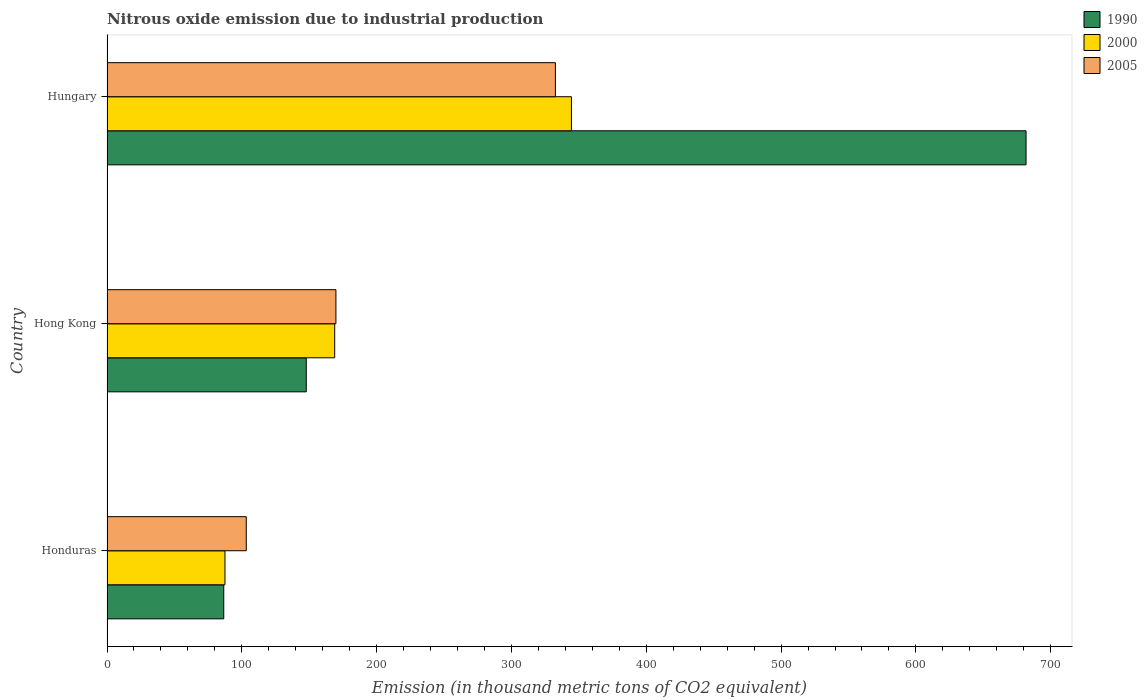How many different coloured bars are there?
Offer a very short reply. 3. How many groups of bars are there?
Provide a short and direct response. 3. Are the number of bars per tick equal to the number of legend labels?
Offer a terse response. Yes. Are the number of bars on each tick of the Y-axis equal?
Ensure brevity in your answer.  Yes. How many bars are there on the 2nd tick from the top?
Your answer should be very brief. 3. What is the label of the 2nd group of bars from the top?
Your response must be concise. Hong Kong. What is the amount of nitrous oxide emitted in 2000 in Hungary?
Provide a short and direct response. 344.5. Across all countries, what is the maximum amount of nitrous oxide emitted in 2000?
Provide a short and direct response. 344.5. Across all countries, what is the minimum amount of nitrous oxide emitted in 1990?
Your response must be concise. 86.6. In which country was the amount of nitrous oxide emitted in 1990 maximum?
Offer a very short reply. Hungary. In which country was the amount of nitrous oxide emitted in 2005 minimum?
Provide a short and direct response. Honduras. What is the total amount of nitrous oxide emitted in 1990 in the graph?
Your answer should be very brief. 916.1. What is the difference between the amount of nitrous oxide emitted in 2005 in Hong Kong and that in Hungary?
Your answer should be compact. -162.8. What is the difference between the amount of nitrous oxide emitted in 1990 in Hong Kong and the amount of nitrous oxide emitted in 2000 in Hungary?
Ensure brevity in your answer.  -196.7. What is the average amount of nitrous oxide emitted in 1990 per country?
Your answer should be compact. 305.37. What is the difference between the amount of nitrous oxide emitted in 2005 and amount of nitrous oxide emitted in 2000 in Hungary?
Your answer should be compact. -11.9. What is the ratio of the amount of nitrous oxide emitted in 2000 in Honduras to that in Hungary?
Provide a succinct answer. 0.25. Is the amount of nitrous oxide emitted in 1990 in Honduras less than that in Hong Kong?
Your response must be concise. Yes. Is the difference between the amount of nitrous oxide emitted in 2005 in Hong Kong and Hungary greater than the difference between the amount of nitrous oxide emitted in 2000 in Hong Kong and Hungary?
Your response must be concise. Yes. What is the difference between the highest and the second highest amount of nitrous oxide emitted in 2000?
Your answer should be very brief. 175.6. What is the difference between the highest and the lowest amount of nitrous oxide emitted in 1990?
Ensure brevity in your answer.  595.1. Is the sum of the amount of nitrous oxide emitted in 1990 in Honduras and Hong Kong greater than the maximum amount of nitrous oxide emitted in 2005 across all countries?
Offer a terse response. No. How many bars are there?
Offer a terse response. 9. Are all the bars in the graph horizontal?
Ensure brevity in your answer.  Yes. What is the difference between two consecutive major ticks on the X-axis?
Your answer should be very brief. 100. Are the values on the major ticks of X-axis written in scientific E-notation?
Make the answer very short. No. Does the graph contain any zero values?
Your answer should be compact. No. Where does the legend appear in the graph?
Keep it short and to the point. Top right. What is the title of the graph?
Your answer should be compact. Nitrous oxide emission due to industrial production. What is the label or title of the X-axis?
Provide a succinct answer. Emission (in thousand metric tons of CO2 equivalent). What is the Emission (in thousand metric tons of CO2 equivalent) in 1990 in Honduras?
Make the answer very short. 86.6. What is the Emission (in thousand metric tons of CO2 equivalent) of 2000 in Honduras?
Your answer should be compact. 87.5. What is the Emission (in thousand metric tons of CO2 equivalent) in 2005 in Honduras?
Keep it short and to the point. 103.3. What is the Emission (in thousand metric tons of CO2 equivalent) of 1990 in Hong Kong?
Give a very brief answer. 147.8. What is the Emission (in thousand metric tons of CO2 equivalent) of 2000 in Hong Kong?
Your answer should be compact. 168.9. What is the Emission (in thousand metric tons of CO2 equivalent) in 2005 in Hong Kong?
Make the answer very short. 169.8. What is the Emission (in thousand metric tons of CO2 equivalent) of 1990 in Hungary?
Provide a succinct answer. 681.7. What is the Emission (in thousand metric tons of CO2 equivalent) of 2000 in Hungary?
Give a very brief answer. 344.5. What is the Emission (in thousand metric tons of CO2 equivalent) of 2005 in Hungary?
Offer a very short reply. 332.6. Across all countries, what is the maximum Emission (in thousand metric tons of CO2 equivalent) of 1990?
Ensure brevity in your answer.  681.7. Across all countries, what is the maximum Emission (in thousand metric tons of CO2 equivalent) of 2000?
Keep it short and to the point. 344.5. Across all countries, what is the maximum Emission (in thousand metric tons of CO2 equivalent) of 2005?
Provide a short and direct response. 332.6. Across all countries, what is the minimum Emission (in thousand metric tons of CO2 equivalent) of 1990?
Provide a short and direct response. 86.6. Across all countries, what is the minimum Emission (in thousand metric tons of CO2 equivalent) of 2000?
Offer a very short reply. 87.5. Across all countries, what is the minimum Emission (in thousand metric tons of CO2 equivalent) of 2005?
Your response must be concise. 103.3. What is the total Emission (in thousand metric tons of CO2 equivalent) of 1990 in the graph?
Give a very brief answer. 916.1. What is the total Emission (in thousand metric tons of CO2 equivalent) in 2000 in the graph?
Your response must be concise. 600.9. What is the total Emission (in thousand metric tons of CO2 equivalent) in 2005 in the graph?
Ensure brevity in your answer.  605.7. What is the difference between the Emission (in thousand metric tons of CO2 equivalent) of 1990 in Honduras and that in Hong Kong?
Make the answer very short. -61.2. What is the difference between the Emission (in thousand metric tons of CO2 equivalent) in 2000 in Honduras and that in Hong Kong?
Your answer should be compact. -81.4. What is the difference between the Emission (in thousand metric tons of CO2 equivalent) of 2005 in Honduras and that in Hong Kong?
Offer a very short reply. -66.5. What is the difference between the Emission (in thousand metric tons of CO2 equivalent) in 1990 in Honduras and that in Hungary?
Provide a succinct answer. -595.1. What is the difference between the Emission (in thousand metric tons of CO2 equivalent) in 2000 in Honduras and that in Hungary?
Offer a very short reply. -257. What is the difference between the Emission (in thousand metric tons of CO2 equivalent) of 2005 in Honduras and that in Hungary?
Your response must be concise. -229.3. What is the difference between the Emission (in thousand metric tons of CO2 equivalent) in 1990 in Hong Kong and that in Hungary?
Make the answer very short. -533.9. What is the difference between the Emission (in thousand metric tons of CO2 equivalent) in 2000 in Hong Kong and that in Hungary?
Keep it short and to the point. -175.6. What is the difference between the Emission (in thousand metric tons of CO2 equivalent) in 2005 in Hong Kong and that in Hungary?
Provide a succinct answer. -162.8. What is the difference between the Emission (in thousand metric tons of CO2 equivalent) in 1990 in Honduras and the Emission (in thousand metric tons of CO2 equivalent) in 2000 in Hong Kong?
Provide a short and direct response. -82.3. What is the difference between the Emission (in thousand metric tons of CO2 equivalent) of 1990 in Honduras and the Emission (in thousand metric tons of CO2 equivalent) of 2005 in Hong Kong?
Your answer should be very brief. -83.2. What is the difference between the Emission (in thousand metric tons of CO2 equivalent) of 2000 in Honduras and the Emission (in thousand metric tons of CO2 equivalent) of 2005 in Hong Kong?
Provide a short and direct response. -82.3. What is the difference between the Emission (in thousand metric tons of CO2 equivalent) of 1990 in Honduras and the Emission (in thousand metric tons of CO2 equivalent) of 2000 in Hungary?
Provide a succinct answer. -257.9. What is the difference between the Emission (in thousand metric tons of CO2 equivalent) of 1990 in Honduras and the Emission (in thousand metric tons of CO2 equivalent) of 2005 in Hungary?
Ensure brevity in your answer.  -246. What is the difference between the Emission (in thousand metric tons of CO2 equivalent) in 2000 in Honduras and the Emission (in thousand metric tons of CO2 equivalent) in 2005 in Hungary?
Provide a succinct answer. -245.1. What is the difference between the Emission (in thousand metric tons of CO2 equivalent) in 1990 in Hong Kong and the Emission (in thousand metric tons of CO2 equivalent) in 2000 in Hungary?
Make the answer very short. -196.7. What is the difference between the Emission (in thousand metric tons of CO2 equivalent) in 1990 in Hong Kong and the Emission (in thousand metric tons of CO2 equivalent) in 2005 in Hungary?
Give a very brief answer. -184.8. What is the difference between the Emission (in thousand metric tons of CO2 equivalent) of 2000 in Hong Kong and the Emission (in thousand metric tons of CO2 equivalent) of 2005 in Hungary?
Provide a succinct answer. -163.7. What is the average Emission (in thousand metric tons of CO2 equivalent) of 1990 per country?
Offer a very short reply. 305.37. What is the average Emission (in thousand metric tons of CO2 equivalent) in 2000 per country?
Ensure brevity in your answer.  200.3. What is the average Emission (in thousand metric tons of CO2 equivalent) in 2005 per country?
Your response must be concise. 201.9. What is the difference between the Emission (in thousand metric tons of CO2 equivalent) in 1990 and Emission (in thousand metric tons of CO2 equivalent) in 2000 in Honduras?
Offer a terse response. -0.9. What is the difference between the Emission (in thousand metric tons of CO2 equivalent) in 1990 and Emission (in thousand metric tons of CO2 equivalent) in 2005 in Honduras?
Your answer should be compact. -16.7. What is the difference between the Emission (in thousand metric tons of CO2 equivalent) of 2000 and Emission (in thousand metric tons of CO2 equivalent) of 2005 in Honduras?
Provide a short and direct response. -15.8. What is the difference between the Emission (in thousand metric tons of CO2 equivalent) in 1990 and Emission (in thousand metric tons of CO2 equivalent) in 2000 in Hong Kong?
Your response must be concise. -21.1. What is the difference between the Emission (in thousand metric tons of CO2 equivalent) in 1990 and Emission (in thousand metric tons of CO2 equivalent) in 2000 in Hungary?
Ensure brevity in your answer.  337.2. What is the difference between the Emission (in thousand metric tons of CO2 equivalent) in 1990 and Emission (in thousand metric tons of CO2 equivalent) in 2005 in Hungary?
Provide a short and direct response. 349.1. What is the ratio of the Emission (in thousand metric tons of CO2 equivalent) of 1990 in Honduras to that in Hong Kong?
Provide a succinct answer. 0.59. What is the ratio of the Emission (in thousand metric tons of CO2 equivalent) in 2000 in Honduras to that in Hong Kong?
Your response must be concise. 0.52. What is the ratio of the Emission (in thousand metric tons of CO2 equivalent) in 2005 in Honduras to that in Hong Kong?
Your answer should be compact. 0.61. What is the ratio of the Emission (in thousand metric tons of CO2 equivalent) in 1990 in Honduras to that in Hungary?
Give a very brief answer. 0.13. What is the ratio of the Emission (in thousand metric tons of CO2 equivalent) of 2000 in Honduras to that in Hungary?
Your answer should be compact. 0.25. What is the ratio of the Emission (in thousand metric tons of CO2 equivalent) of 2005 in Honduras to that in Hungary?
Your response must be concise. 0.31. What is the ratio of the Emission (in thousand metric tons of CO2 equivalent) of 1990 in Hong Kong to that in Hungary?
Your response must be concise. 0.22. What is the ratio of the Emission (in thousand metric tons of CO2 equivalent) of 2000 in Hong Kong to that in Hungary?
Make the answer very short. 0.49. What is the ratio of the Emission (in thousand metric tons of CO2 equivalent) in 2005 in Hong Kong to that in Hungary?
Make the answer very short. 0.51. What is the difference between the highest and the second highest Emission (in thousand metric tons of CO2 equivalent) of 1990?
Ensure brevity in your answer.  533.9. What is the difference between the highest and the second highest Emission (in thousand metric tons of CO2 equivalent) in 2000?
Your answer should be very brief. 175.6. What is the difference between the highest and the second highest Emission (in thousand metric tons of CO2 equivalent) in 2005?
Your response must be concise. 162.8. What is the difference between the highest and the lowest Emission (in thousand metric tons of CO2 equivalent) of 1990?
Offer a terse response. 595.1. What is the difference between the highest and the lowest Emission (in thousand metric tons of CO2 equivalent) in 2000?
Ensure brevity in your answer.  257. What is the difference between the highest and the lowest Emission (in thousand metric tons of CO2 equivalent) of 2005?
Offer a very short reply. 229.3. 